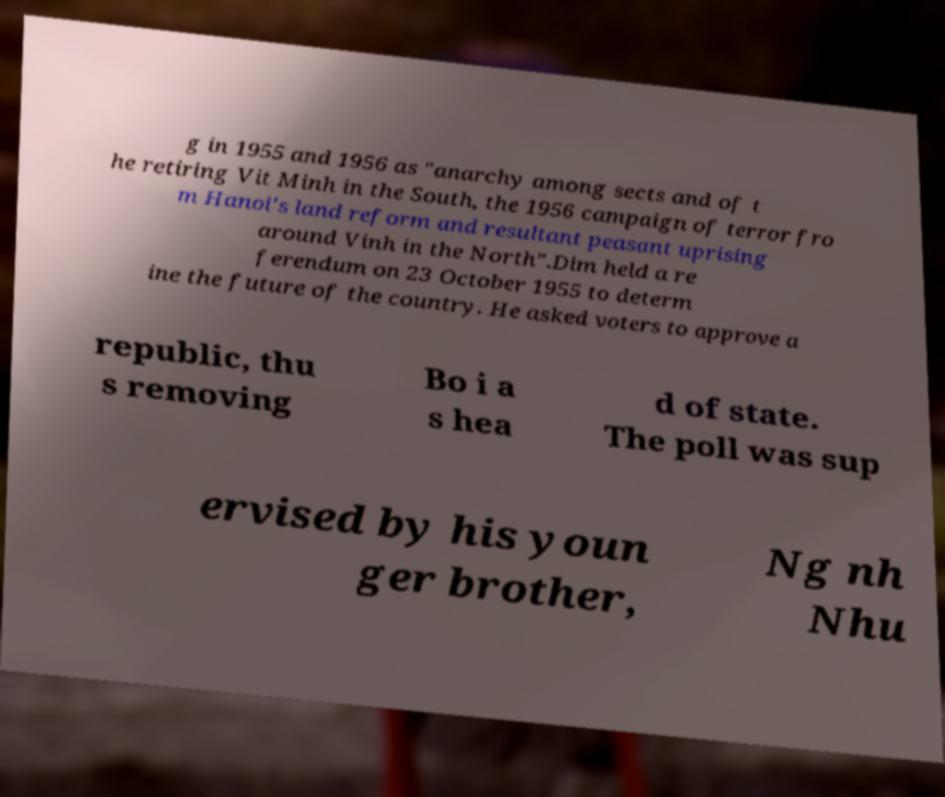Could you extract and type out the text from this image? g in 1955 and 1956 as "anarchy among sects and of t he retiring Vit Minh in the South, the 1956 campaign of terror fro m Hanoi's land reform and resultant peasant uprising around Vinh in the North".Dim held a re ferendum on 23 October 1955 to determ ine the future of the country. He asked voters to approve a republic, thu s removing Bo i a s hea d of state. The poll was sup ervised by his youn ger brother, Ng nh Nhu 